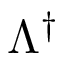Convert formula to latex. <formula><loc_0><loc_0><loc_500><loc_500>\Lambda ^ { \dagger }</formula> 